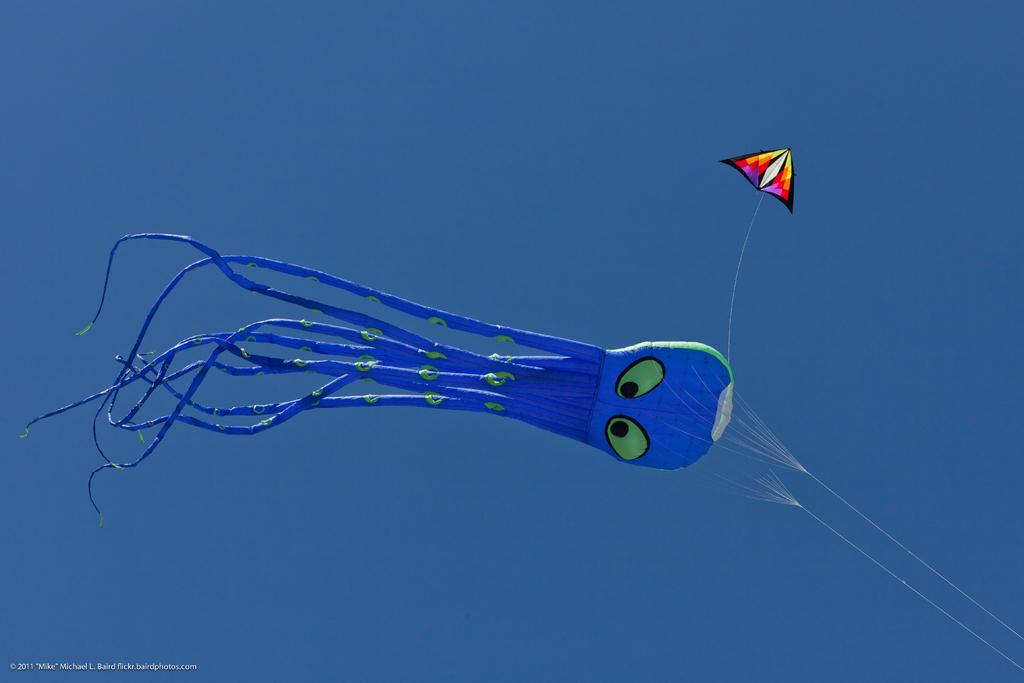What is flying in the air in the image? There is an air-filled balloon and a kite flying in the air in the image. Can you describe the balloon in the image? The balloon is air-filled and is flying in the air. What else is flying in the air besides the balloon? There is also a kite flying in the air in the image. How many legs can be seen on the balloon in the image? There are no legs visible on the balloon in the image, as it is an air-filled object and not a living creature. 